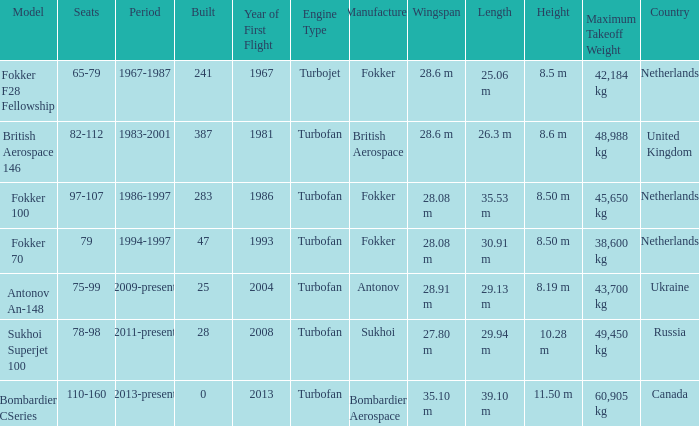How many cabins were built in the time between 1967-1987? 241.0. I'm looking to parse the entire table for insights. Could you assist me with that? {'header': ['Model', 'Seats', 'Period', 'Built', 'Year of First Flight', 'Engine Type', 'Manufacturer', 'Wingspan', 'Length', 'Height', 'Maximum Takeoff Weight', 'Country'], 'rows': [['Fokker F28 Fellowship', '65-79', '1967-1987', '241', '1967', 'Turbojet', 'Fokker', '28.6 m', '25.06 m', '8.5 m', '42,184 kg', 'Netherlands'], ['British Aerospace 146', '82-112', '1983-2001', '387', '1981', 'Turbofan', 'British Aerospace', '28.6 m', '26.3 m', '8.6 m', '48,988 kg', 'United Kingdom'], ['Fokker 100', '97-107', '1986-1997', '283', '1986', 'Turbofan', 'Fokker', '28.08 m', '35.53 m', '8.50 m', '45,650 kg', 'Netherlands'], ['Fokker 70', '79', '1994-1997', '47', '1993', 'Turbofan', 'Fokker', '28.08 m', '30.91 m', '8.50 m', '38,600 kg', 'Netherlands'], ['Antonov An-148', '75-99', '2009-present', '25', '2004', 'Turbofan', 'Antonov', '28.91 m', '29.13 m', '8.19 m', '43,700 kg', 'Ukraine'], ['Sukhoi Superjet 100', '78-98', '2011-present', '28', '2008', 'Turbofan', 'Sukhoi', '27.80 m', '29.94 m', '10.28 m', '49,450 kg', 'Russia'], ['Bombardier CSeries', '110-160', '2013-present', '0', '2013', 'Turbofan', 'Bombardier Aerospace', '35.10 m', '39.10 m', '11.50 m', '60,905 kg', 'Canada']]} 